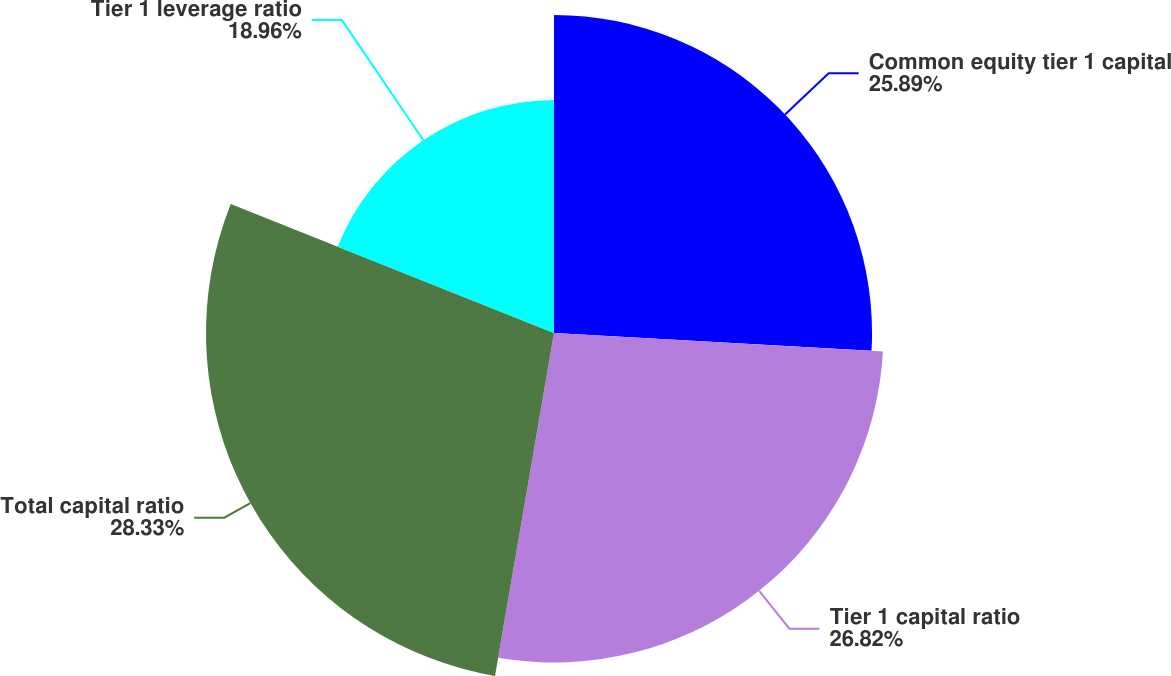Convert chart to OTSL. <chart><loc_0><loc_0><loc_500><loc_500><pie_chart><fcel>Common equity tier 1 capital<fcel>Tier 1 capital ratio<fcel>Total capital ratio<fcel>Tier 1 leverage ratio<nl><fcel>25.89%<fcel>26.82%<fcel>28.33%<fcel>18.96%<nl></chart> 